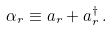<formula> <loc_0><loc_0><loc_500><loc_500>\alpha _ { r } \equiv a _ { r } + a _ { r } ^ { \dagger } \, .</formula> 